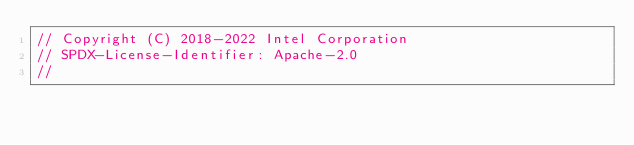<code> <loc_0><loc_0><loc_500><loc_500><_C++_>// Copyright (C) 2018-2022 Intel Corporation
// SPDX-License-Identifier: Apache-2.0
//
</code> 